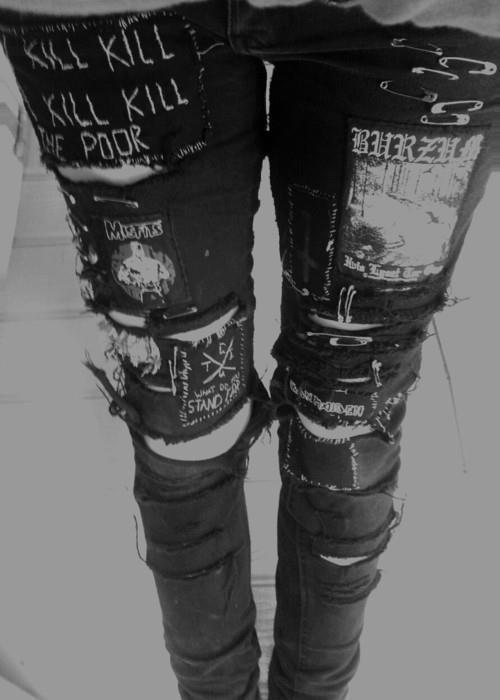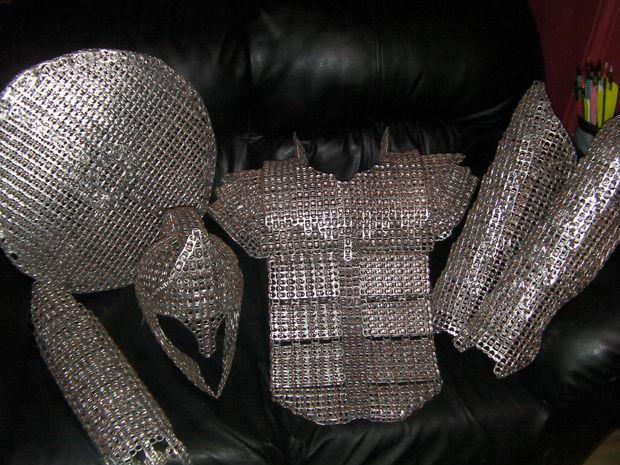The first image is the image on the left, the second image is the image on the right. Analyze the images presented: Is the assertion "There is a black shirt with a peace sign on it and a black collared jacket." valid? Answer yes or no. No. The first image is the image on the left, the second image is the image on the right. Examine the images to the left and right. Is the description "there is a black top with the peace sihn made from bobby pins" accurate? Answer yes or no. No. 